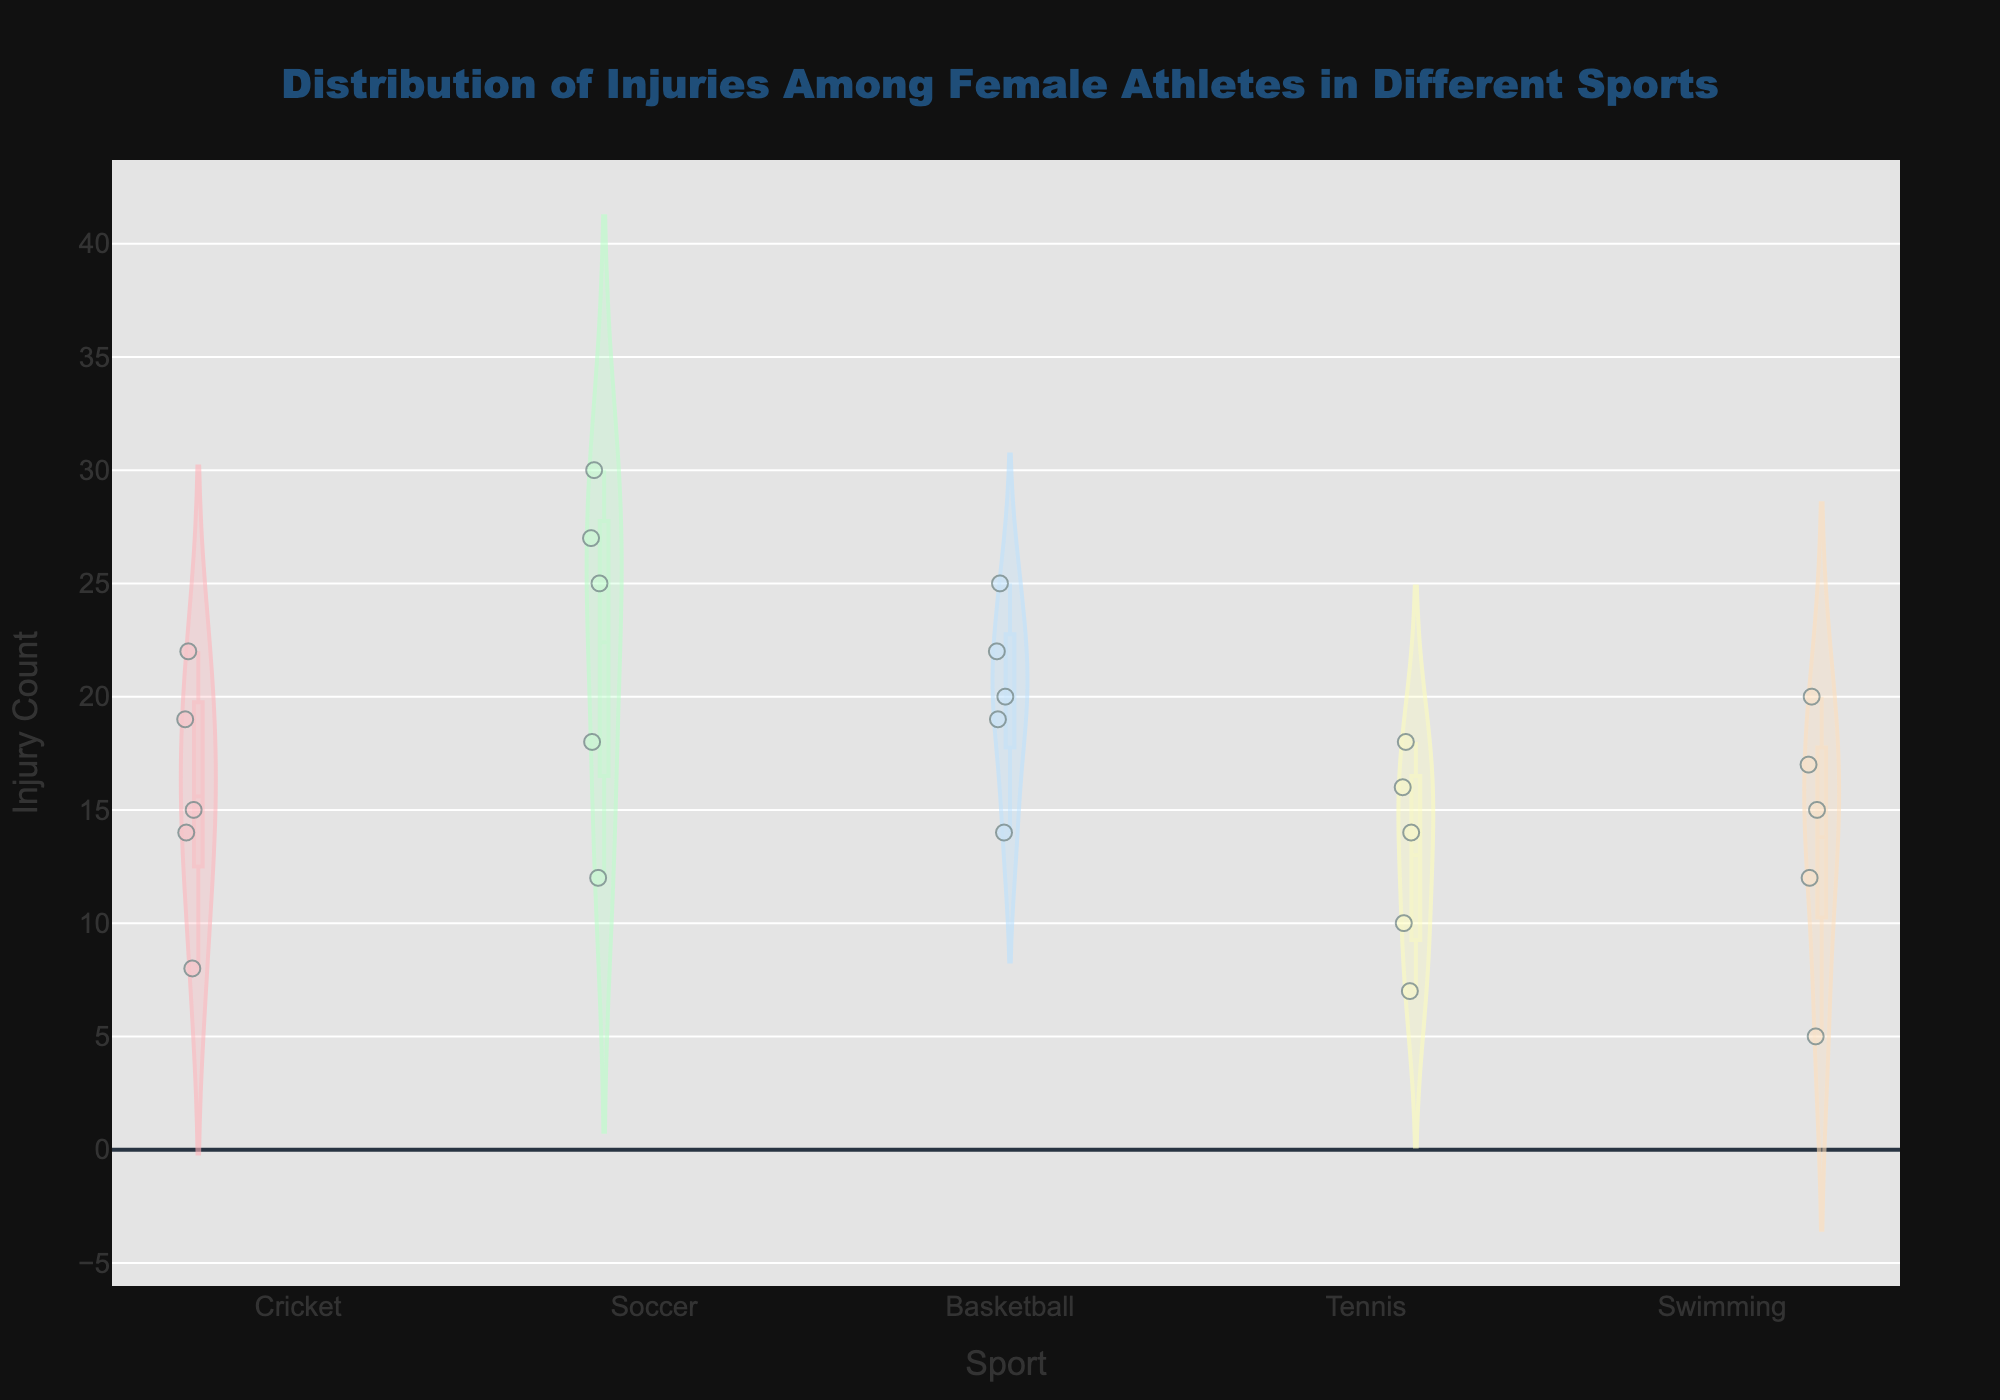What is the title of the figure? The title can be found at the top of the figure, which indicates what the entire diagram represents.
Answer: Distribution of Injuries Among Female Athletes in Different Sports Which sport has the highest count of injuries based on the figure? Look at the sport where the violin plot is stretched the highest along the y-axis.
Answer: Soccer How many data points are used for Cricket? Count the individual points within the Cricket section in the violin plot.
Answer: 5 What's the median injury count for Basketball, and how is it visually identified? The median can be identified by looking at the line within the box plot of the Basketball violin plot.
Answer: 20 Between Tennis and Swimming, which sport has a greater range of injury counts? Locate the top and bottom of the violin plots for Tennis and Swimming, respectively, and compare the range.
Answer: Swimming What is the mean injury count for Soccer? Locate the mean line in the Soccer violin plot, which represents the average value among all points.
Answer: 22.4 Is the distribution of injuries in Cricket wider or narrower compared to Tennis? Compare the width of the violin plots for Cricket and Tennis; wider plots indicate more variability.
Answer: Narrower Which sport has the least variability in injury counts? Find the sport with the least spread in the violin plot, indicating the smallest range.
Answer: Tennis Does any sport display an annotation related to cricket? Check the annotations in the figure. There should be one related to cricket at the bottom.
Answer: Yes Based on the visuals, which two sports have the closest median injury count? Identify the middle line in the box plots for each sport and compare them to find the closest medians.
Answer: Cricket and Basketball 